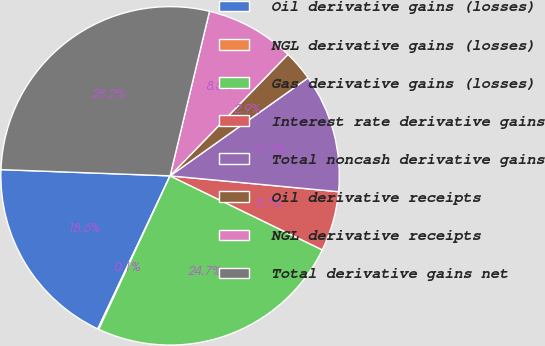Convert chart. <chart><loc_0><loc_0><loc_500><loc_500><pie_chart><fcel>Oil derivative gains (losses)<fcel>NGL derivative gains (losses)<fcel>Gas derivative gains (losses)<fcel>Interest rate derivative gains<fcel>Total noncash derivative gains<fcel>Oil derivative receipts<fcel>NGL derivative receipts<fcel>Total derivative gains net<nl><fcel>18.56%<fcel>0.1%<fcel>24.72%<fcel>5.71%<fcel>11.32%<fcel>2.91%<fcel>8.52%<fcel>28.15%<nl></chart> 